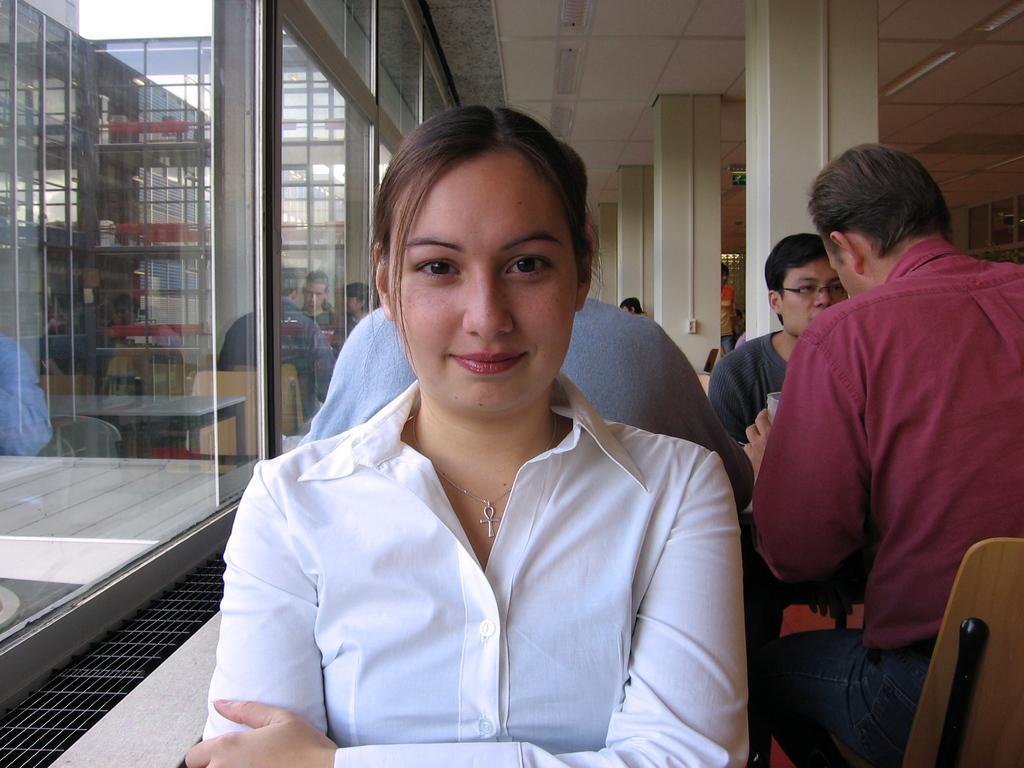Describe this image in one or two sentences. In this image I can see a group of people are sitting on the chairs in front of a table. In the background I can see pillars, glass windows and a rooftop. This image is taken may be in a restaurant. 